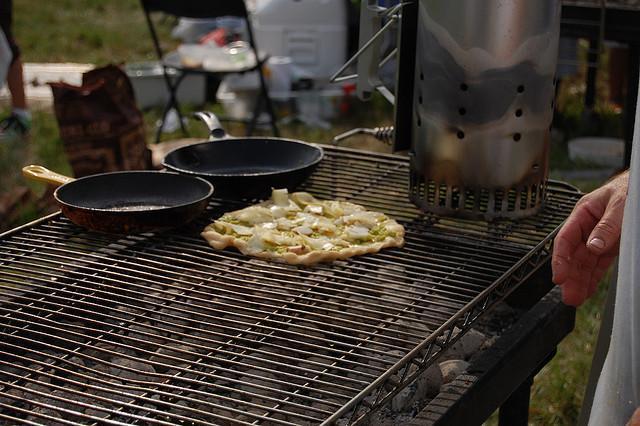How many pans are shown?
Give a very brief answer. 2. How many knives are in the picture?
Give a very brief answer. 0. How many hamburgers are being cooked?
Give a very brief answer. 0. How many people are there?
Give a very brief answer. 2. 